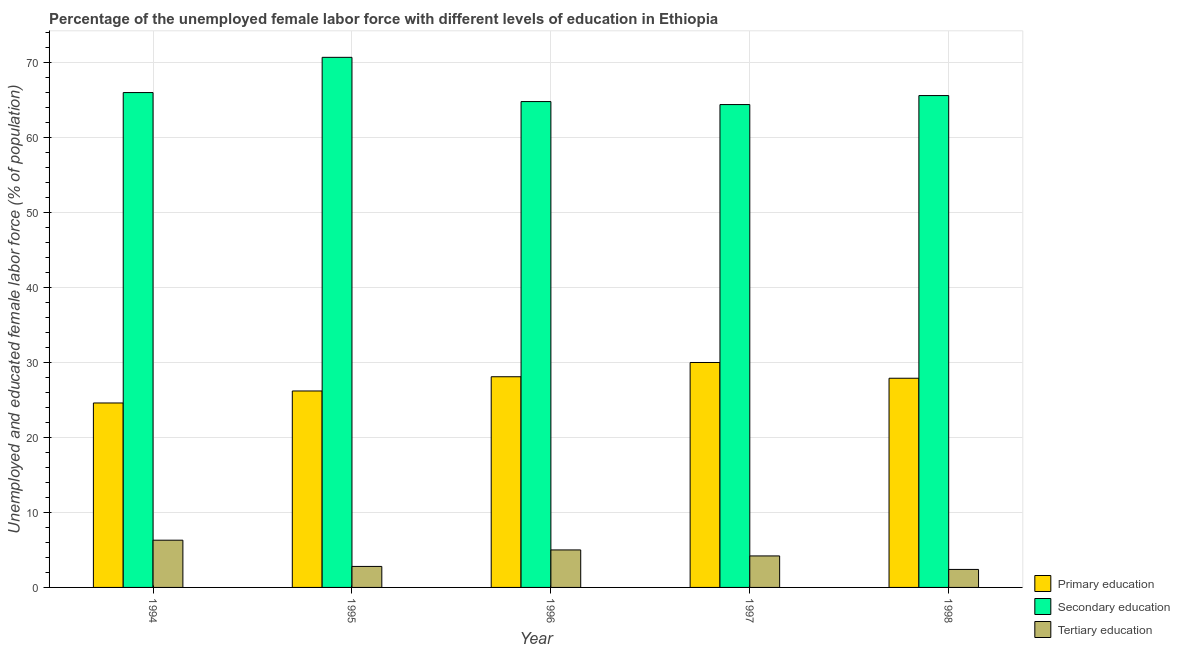How many different coloured bars are there?
Provide a succinct answer. 3. How many groups of bars are there?
Your response must be concise. 5. Are the number of bars per tick equal to the number of legend labels?
Keep it short and to the point. Yes. Are the number of bars on each tick of the X-axis equal?
Keep it short and to the point. Yes. How many bars are there on the 5th tick from the left?
Offer a terse response. 3. Across all years, what is the maximum percentage of female labor force who received secondary education?
Your answer should be compact. 70.7. Across all years, what is the minimum percentage of female labor force who received primary education?
Your answer should be compact. 24.6. In which year was the percentage of female labor force who received tertiary education minimum?
Your answer should be very brief. 1998. What is the total percentage of female labor force who received primary education in the graph?
Make the answer very short. 136.8. What is the difference between the percentage of female labor force who received tertiary education in 1995 and that in 1996?
Provide a short and direct response. -2.2. What is the difference between the percentage of female labor force who received secondary education in 1996 and the percentage of female labor force who received primary education in 1994?
Offer a very short reply. -1.2. What is the average percentage of female labor force who received secondary education per year?
Provide a short and direct response. 66.3. In how many years, is the percentage of female labor force who received secondary education greater than 20 %?
Offer a terse response. 5. What is the ratio of the percentage of female labor force who received secondary education in 1995 to that in 1998?
Your answer should be very brief. 1.08. What is the difference between the highest and the second highest percentage of female labor force who received primary education?
Offer a terse response. 1.9. What is the difference between the highest and the lowest percentage of female labor force who received secondary education?
Offer a terse response. 6.3. In how many years, is the percentage of female labor force who received secondary education greater than the average percentage of female labor force who received secondary education taken over all years?
Your response must be concise. 1. What does the 1st bar from the left in 1994 represents?
Your answer should be compact. Primary education. What does the 3rd bar from the right in 1996 represents?
Offer a very short reply. Primary education. Is it the case that in every year, the sum of the percentage of female labor force who received primary education and percentage of female labor force who received secondary education is greater than the percentage of female labor force who received tertiary education?
Provide a short and direct response. Yes. How many bars are there?
Offer a terse response. 15. Are all the bars in the graph horizontal?
Offer a terse response. No. Does the graph contain any zero values?
Ensure brevity in your answer.  No. Does the graph contain grids?
Keep it short and to the point. Yes. Where does the legend appear in the graph?
Offer a very short reply. Bottom right. How are the legend labels stacked?
Keep it short and to the point. Vertical. What is the title of the graph?
Offer a terse response. Percentage of the unemployed female labor force with different levels of education in Ethiopia. Does "Female employers" appear as one of the legend labels in the graph?
Give a very brief answer. No. What is the label or title of the X-axis?
Provide a succinct answer. Year. What is the label or title of the Y-axis?
Provide a short and direct response. Unemployed and educated female labor force (% of population). What is the Unemployed and educated female labor force (% of population) in Primary education in 1994?
Offer a terse response. 24.6. What is the Unemployed and educated female labor force (% of population) in Tertiary education in 1994?
Offer a terse response. 6.3. What is the Unemployed and educated female labor force (% of population) of Primary education in 1995?
Give a very brief answer. 26.2. What is the Unemployed and educated female labor force (% of population) of Secondary education in 1995?
Your response must be concise. 70.7. What is the Unemployed and educated female labor force (% of population) of Tertiary education in 1995?
Make the answer very short. 2.8. What is the Unemployed and educated female labor force (% of population) in Primary education in 1996?
Keep it short and to the point. 28.1. What is the Unemployed and educated female labor force (% of population) of Secondary education in 1996?
Make the answer very short. 64.8. What is the Unemployed and educated female labor force (% of population) in Primary education in 1997?
Offer a terse response. 30. What is the Unemployed and educated female labor force (% of population) of Secondary education in 1997?
Your response must be concise. 64.4. What is the Unemployed and educated female labor force (% of population) in Tertiary education in 1997?
Your answer should be very brief. 4.2. What is the Unemployed and educated female labor force (% of population) in Primary education in 1998?
Keep it short and to the point. 27.9. What is the Unemployed and educated female labor force (% of population) of Secondary education in 1998?
Offer a very short reply. 65.6. What is the Unemployed and educated female labor force (% of population) of Tertiary education in 1998?
Ensure brevity in your answer.  2.4. Across all years, what is the maximum Unemployed and educated female labor force (% of population) in Primary education?
Offer a very short reply. 30. Across all years, what is the maximum Unemployed and educated female labor force (% of population) in Secondary education?
Provide a short and direct response. 70.7. Across all years, what is the maximum Unemployed and educated female labor force (% of population) in Tertiary education?
Offer a terse response. 6.3. Across all years, what is the minimum Unemployed and educated female labor force (% of population) in Primary education?
Offer a very short reply. 24.6. Across all years, what is the minimum Unemployed and educated female labor force (% of population) of Secondary education?
Your answer should be very brief. 64.4. Across all years, what is the minimum Unemployed and educated female labor force (% of population) of Tertiary education?
Give a very brief answer. 2.4. What is the total Unemployed and educated female labor force (% of population) of Primary education in the graph?
Offer a terse response. 136.8. What is the total Unemployed and educated female labor force (% of population) of Secondary education in the graph?
Provide a succinct answer. 331.5. What is the total Unemployed and educated female labor force (% of population) of Tertiary education in the graph?
Your answer should be compact. 20.7. What is the difference between the Unemployed and educated female labor force (% of population) in Primary education in 1994 and that in 1995?
Offer a terse response. -1.6. What is the difference between the Unemployed and educated female labor force (% of population) in Secondary education in 1994 and that in 1995?
Provide a short and direct response. -4.7. What is the difference between the Unemployed and educated female labor force (% of population) of Tertiary education in 1994 and that in 1995?
Your answer should be very brief. 3.5. What is the difference between the Unemployed and educated female labor force (% of population) in Secondary education in 1994 and that in 1996?
Your answer should be very brief. 1.2. What is the difference between the Unemployed and educated female labor force (% of population) in Tertiary education in 1994 and that in 1996?
Provide a short and direct response. 1.3. What is the difference between the Unemployed and educated female labor force (% of population) of Tertiary education in 1994 and that in 1997?
Provide a short and direct response. 2.1. What is the difference between the Unemployed and educated female labor force (% of population) in Primary education in 1994 and that in 1998?
Keep it short and to the point. -3.3. What is the difference between the Unemployed and educated female labor force (% of population) of Secondary education in 1994 and that in 1998?
Offer a terse response. 0.4. What is the difference between the Unemployed and educated female labor force (% of population) of Primary education in 1995 and that in 1996?
Offer a very short reply. -1.9. What is the difference between the Unemployed and educated female labor force (% of population) of Secondary education in 1995 and that in 1996?
Your answer should be compact. 5.9. What is the difference between the Unemployed and educated female labor force (% of population) in Tertiary education in 1995 and that in 1996?
Make the answer very short. -2.2. What is the difference between the Unemployed and educated female labor force (% of population) in Secondary education in 1995 and that in 1997?
Your answer should be compact. 6.3. What is the difference between the Unemployed and educated female labor force (% of population) in Tertiary education in 1995 and that in 1997?
Your answer should be very brief. -1.4. What is the difference between the Unemployed and educated female labor force (% of population) in Primary education in 1995 and that in 1998?
Your answer should be very brief. -1.7. What is the difference between the Unemployed and educated female labor force (% of population) in Tertiary education in 1995 and that in 1998?
Make the answer very short. 0.4. What is the difference between the Unemployed and educated female labor force (% of population) in Secondary education in 1996 and that in 1998?
Offer a very short reply. -0.8. What is the difference between the Unemployed and educated female labor force (% of population) of Primary education in 1997 and that in 1998?
Provide a succinct answer. 2.1. What is the difference between the Unemployed and educated female labor force (% of population) of Secondary education in 1997 and that in 1998?
Offer a very short reply. -1.2. What is the difference between the Unemployed and educated female labor force (% of population) in Tertiary education in 1997 and that in 1998?
Your response must be concise. 1.8. What is the difference between the Unemployed and educated female labor force (% of population) of Primary education in 1994 and the Unemployed and educated female labor force (% of population) of Secondary education in 1995?
Offer a very short reply. -46.1. What is the difference between the Unemployed and educated female labor force (% of population) in Primary education in 1994 and the Unemployed and educated female labor force (% of population) in Tertiary education in 1995?
Offer a terse response. 21.8. What is the difference between the Unemployed and educated female labor force (% of population) in Secondary education in 1994 and the Unemployed and educated female labor force (% of population) in Tertiary education in 1995?
Offer a terse response. 63.2. What is the difference between the Unemployed and educated female labor force (% of population) of Primary education in 1994 and the Unemployed and educated female labor force (% of population) of Secondary education in 1996?
Provide a short and direct response. -40.2. What is the difference between the Unemployed and educated female labor force (% of population) of Primary education in 1994 and the Unemployed and educated female labor force (% of population) of Tertiary education in 1996?
Offer a terse response. 19.6. What is the difference between the Unemployed and educated female labor force (% of population) of Secondary education in 1994 and the Unemployed and educated female labor force (% of population) of Tertiary education in 1996?
Offer a terse response. 61. What is the difference between the Unemployed and educated female labor force (% of population) in Primary education in 1994 and the Unemployed and educated female labor force (% of population) in Secondary education in 1997?
Offer a very short reply. -39.8. What is the difference between the Unemployed and educated female labor force (% of population) of Primary education in 1994 and the Unemployed and educated female labor force (% of population) of Tertiary education in 1997?
Your answer should be compact. 20.4. What is the difference between the Unemployed and educated female labor force (% of population) of Secondary education in 1994 and the Unemployed and educated female labor force (% of population) of Tertiary education in 1997?
Ensure brevity in your answer.  61.8. What is the difference between the Unemployed and educated female labor force (% of population) in Primary education in 1994 and the Unemployed and educated female labor force (% of population) in Secondary education in 1998?
Your response must be concise. -41. What is the difference between the Unemployed and educated female labor force (% of population) in Secondary education in 1994 and the Unemployed and educated female labor force (% of population) in Tertiary education in 1998?
Your answer should be very brief. 63.6. What is the difference between the Unemployed and educated female labor force (% of population) of Primary education in 1995 and the Unemployed and educated female labor force (% of population) of Secondary education in 1996?
Ensure brevity in your answer.  -38.6. What is the difference between the Unemployed and educated female labor force (% of population) of Primary education in 1995 and the Unemployed and educated female labor force (% of population) of Tertiary education in 1996?
Provide a short and direct response. 21.2. What is the difference between the Unemployed and educated female labor force (% of population) of Secondary education in 1995 and the Unemployed and educated female labor force (% of population) of Tertiary education in 1996?
Your answer should be compact. 65.7. What is the difference between the Unemployed and educated female labor force (% of population) of Primary education in 1995 and the Unemployed and educated female labor force (% of population) of Secondary education in 1997?
Provide a succinct answer. -38.2. What is the difference between the Unemployed and educated female labor force (% of population) of Secondary education in 1995 and the Unemployed and educated female labor force (% of population) of Tertiary education in 1997?
Offer a terse response. 66.5. What is the difference between the Unemployed and educated female labor force (% of population) of Primary education in 1995 and the Unemployed and educated female labor force (% of population) of Secondary education in 1998?
Your answer should be very brief. -39.4. What is the difference between the Unemployed and educated female labor force (% of population) of Primary education in 1995 and the Unemployed and educated female labor force (% of population) of Tertiary education in 1998?
Provide a short and direct response. 23.8. What is the difference between the Unemployed and educated female labor force (% of population) of Secondary education in 1995 and the Unemployed and educated female labor force (% of population) of Tertiary education in 1998?
Your answer should be very brief. 68.3. What is the difference between the Unemployed and educated female labor force (% of population) in Primary education in 1996 and the Unemployed and educated female labor force (% of population) in Secondary education in 1997?
Make the answer very short. -36.3. What is the difference between the Unemployed and educated female labor force (% of population) in Primary education in 1996 and the Unemployed and educated female labor force (% of population) in Tertiary education in 1997?
Offer a very short reply. 23.9. What is the difference between the Unemployed and educated female labor force (% of population) in Secondary education in 1996 and the Unemployed and educated female labor force (% of population) in Tertiary education in 1997?
Provide a short and direct response. 60.6. What is the difference between the Unemployed and educated female labor force (% of population) of Primary education in 1996 and the Unemployed and educated female labor force (% of population) of Secondary education in 1998?
Offer a terse response. -37.5. What is the difference between the Unemployed and educated female labor force (% of population) of Primary education in 1996 and the Unemployed and educated female labor force (% of population) of Tertiary education in 1998?
Provide a short and direct response. 25.7. What is the difference between the Unemployed and educated female labor force (% of population) of Secondary education in 1996 and the Unemployed and educated female labor force (% of population) of Tertiary education in 1998?
Make the answer very short. 62.4. What is the difference between the Unemployed and educated female labor force (% of population) of Primary education in 1997 and the Unemployed and educated female labor force (% of population) of Secondary education in 1998?
Offer a terse response. -35.6. What is the difference between the Unemployed and educated female labor force (% of population) of Primary education in 1997 and the Unemployed and educated female labor force (% of population) of Tertiary education in 1998?
Give a very brief answer. 27.6. What is the average Unemployed and educated female labor force (% of population) in Primary education per year?
Make the answer very short. 27.36. What is the average Unemployed and educated female labor force (% of population) in Secondary education per year?
Offer a very short reply. 66.3. What is the average Unemployed and educated female labor force (% of population) of Tertiary education per year?
Ensure brevity in your answer.  4.14. In the year 1994, what is the difference between the Unemployed and educated female labor force (% of population) of Primary education and Unemployed and educated female labor force (% of population) of Secondary education?
Ensure brevity in your answer.  -41.4. In the year 1994, what is the difference between the Unemployed and educated female labor force (% of population) in Primary education and Unemployed and educated female labor force (% of population) in Tertiary education?
Your response must be concise. 18.3. In the year 1994, what is the difference between the Unemployed and educated female labor force (% of population) in Secondary education and Unemployed and educated female labor force (% of population) in Tertiary education?
Your answer should be very brief. 59.7. In the year 1995, what is the difference between the Unemployed and educated female labor force (% of population) of Primary education and Unemployed and educated female labor force (% of population) of Secondary education?
Ensure brevity in your answer.  -44.5. In the year 1995, what is the difference between the Unemployed and educated female labor force (% of population) in Primary education and Unemployed and educated female labor force (% of population) in Tertiary education?
Your answer should be very brief. 23.4. In the year 1995, what is the difference between the Unemployed and educated female labor force (% of population) in Secondary education and Unemployed and educated female labor force (% of population) in Tertiary education?
Your answer should be very brief. 67.9. In the year 1996, what is the difference between the Unemployed and educated female labor force (% of population) in Primary education and Unemployed and educated female labor force (% of population) in Secondary education?
Your answer should be compact. -36.7. In the year 1996, what is the difference between the Unemployed and educated female labor force (% of population) of Primary education and Unemployed and educated female labor force (% of population) of Tertiary education?
Provide a short and direct response. 23.1. In the year 1996, what is the difference between the Unemployed and educated female labor force (% of population) of Secondary education and Unemployed and educated female labor force (% of population) of Tertiary education?
Keep it short and to the point. 59.8. In the year 1997, what is the difference between the Unemployed and educated female labor force (% of population) in Primary education and Unemployed and educated female labor force (% of population) in Secondary education?
Offer a terse response. -34.4. In the year 1997, what is the difference between the Unemployed and educated female labor force (% of population) in Primary education and Unemployed and educated female labor force (% of population) in Tertiary education?
Keep it short and to the point. 25.8. In the year 1997, what is the difference between the Unemployed and educated female labor force (% of population) of Secondary education and Unemployed and educated female labor force (% of population) of Tertiary education?
Make the answer very short. 60.2. In the year 1998, what is the difference between the Unemployed and educated female labor force (% of population) in Primary education and Unemployed and educated female labor force (% of population) in Secondary education?
Offer a very short reply. -37.7. In the year 1998, what is the difference between the Unemployed and educated female labor force (% of population) of Secondary education and Unemployed and educated female labor force (% of population) of Tertiary education?
Your answer should be compact. 63.2. What is the ratio of the Unemployed and educated female labor force (% of population) of Primary education in 1994 to that in 1995?
Give a very brief answer. 0.94. What is the ratio of the Unemployed and educated female labor force (% of population) in Secondary education in 1994 to that in 1995?
Your answer should be compact. 0.93. What is the ratio of the Unemployed and educated female labor force (% of population) of Tertiary education in 1994 to that in 1995?
Provide a succinct answer. 2.25. What is the ratio of the Unemployed and educated female labor force (% of population) in Primary education in 1994 to that in 1996?
Ensure brevity in your answer.  0.88. What is the ratio of the Unemployed and educated female labor force (% of population) in Secondary education in 1994 to that in 1996?
Make the answer very short. 1.02. What is the ratio of the Unemployed and educated female labor force (% of population) in Tertiary education in 1994 to that in 1996?
Make the answer very short. 1.26. What is the ratio of the Unemployed and educated female labor force (% of population) of Primary education in 1994 to that in 1997?
Your answer should be compact. 0.82. What is the ratio of the Unemployed and educated female labor force (% of population) of Secondary education in 1994 to that in 1997?
Your answer should be compact. 1.02. What is the ratio of the Unemployed and educated female labor force (% of population) of Primary education in 1994 to that in 1998?
Provide a short and direct response. 0.88. What is the ratio of the Unemployed and educated female labor force (% of population) of Tertiary education in 1994 to that in 1998?
Your response must be concise. 2.62. What is the ratio of the Unemployed and educated female labor force (% of population) of Primary education in 1995 to that in 1996?
Your response must be concise. 0.93. What is the ratio of the Unemployed and educated female labor force (% of population) of Secondary education in 1995 to that in 1996?
Ensure brevity in your answer.  1.09. What is the ratio of the Unemployed and educated female labor force (% of population) in Tertiary education in 1995 to that in 1996?
Provide a short and direct response. 0.56. What is the ratio of the Unemployed and educated female labor force (% of population) of Primary education in 1995 to that in 1997?
Ensure brevity in your answer.  0.87. What is the ratio of the Unemployed and educated female labor force (% of population) of Secondary education in 1995 to that in 1997?
Give a very brief answer. 1.1. What is the ratio of the Unemployed and educated female labor force (% of population) in Tertiary education in 1995 to that in 1997?
Offer a terse response. 0.67. What is the ratio of the Unemployed and educated female labor force (% of population) of Primary education in 1995 to that in 1998?
Provide a short and direct response. 0.94. What is the ratio of the Unemployed and educated female labor force (% of population) in Secondary education in 1995 to that in 1998?
Your answer should be compact. 1.08. What is the ratio of the Unemployed and educated female labor force (% of population) of Tertiary education in 1995 to that in 1998?
Make the answer very short. 1.17. What is the ratio of the Unemployed and educated female labor force (% of population) of Primary education in 1996 to that in 1997?
Keep it short and to the point. 0.94. What is the ratio of the Unemployed and educated female labor force (% of population) of Tertiary education in 1996 to that in 1997?
Give a very brief answer. 1.19. What is the ratio of the Unemployed and educated female labor force (% of population) in Secondary education in 1996 to that in 1998?
Provide a succinct answer. 0.99. What is the ratio of the Unemployed and educated female labor force (% of population) of Tertiary education in 1996 to that in 1998?
Make the answer very short. 2.08. What is the ratio of the Unemployed and educated female labor force (% of population) of Primary education in 1997 to that in 1998?
Give a very brief answer. 1.08. What is the ratio of the Unemployed and educated female labor force (% of population) of Secondary education in 1997 to that in 1998?
Provide a succinct answer. 0.98. What is the ratio of the Unemployed and educated female labor force (% of population) in Tertiary education in 1997 to that in 1998?
Your response must be concise. 1.75. What is the difference between the highest and the second highest Unemployed and educated female labor force (% of population) of Primary education?
Provide a short and direct response. 1.9. What is the difference between the highest and the second highest Unemployed and educated female labor force (% of population) in Secondary education?
Give a very brief answer. 4.7. What is the difference between the highest and the lowest Unemployed and educated female labor force (% of population) of Secondary education?
Offer a terse response. 6.3. What is the difference between the highest and the lowest Unemployed and educated female labor force (% of population) in Tertiary education?
Provide a succinct answer. 3.9. 